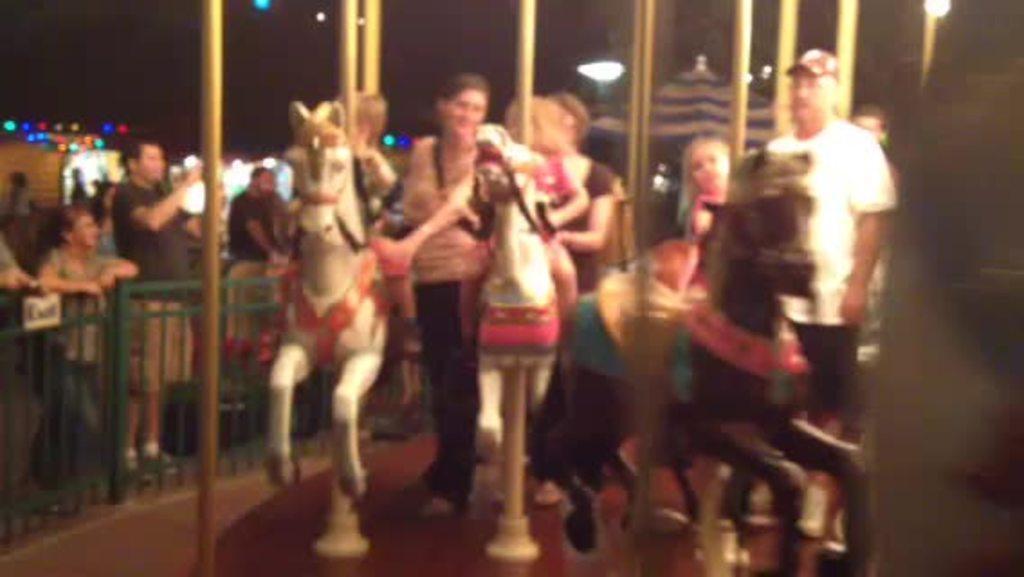Could you give a brief overview of what you see in this image? In this image I can see there are persons standing. And few persons are sitting on a playing horse. And few persons are watching. There is a fence, Shed, Pole in between horse. And there are a tent and lights. 